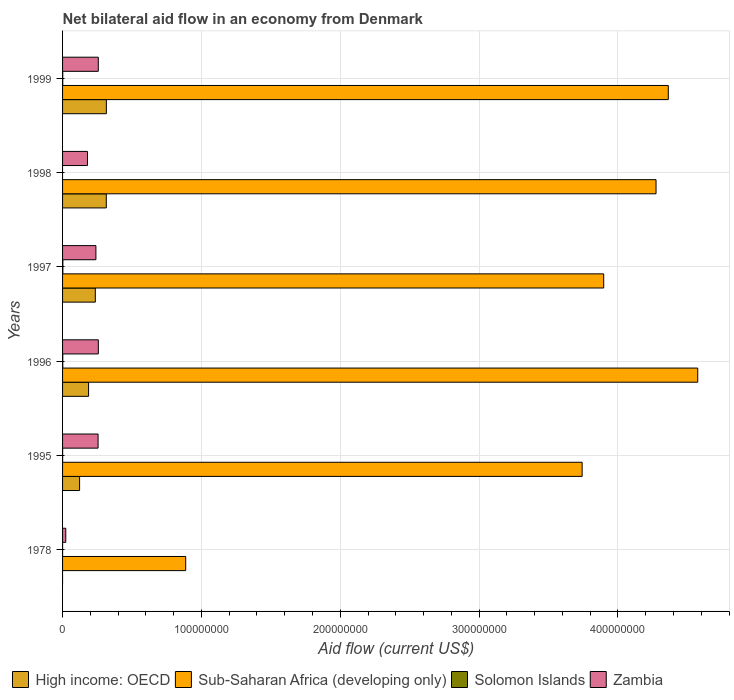Are the number of bars on each tick of the Y-axis equal?
Give a very brief answer. No. How many bars are there on the 4th tick from the top?
Ensure brevity in your answer.  4. How many bars are there on the 1st tick from the bottom?
Your response must be concise. 3. What is the label of the 1st group of bars from the top?
Your response must be concise. 1999. What is the net bilateral aid flow in High income: OECD in 1997?
Keep it short and to the point. 2.36e+07. Across all years, what is the maximum net bilateral aid flow in High income: OECD?
Your response must be concise. 3.15e+07. Across all years, what is the minimum net bilateral aid flow in Solomon Islands?
Provide a short and direct response. 0. In which year was the net bilateral aid flow in Zambia maximum?
Offer a very short reply. 1996. What is the total net bilateral aid flow in Sub-Saharan Africa (developing only) in the graph?
Make the answer very short. 2.17e+09. What is the difference between the net bilateral aid flow in High income: OECD in 1996 and that in 1997?
Provide a succinct answer. -4.87e+06. What is the difference between the net bilateral aid flow in Sub-Saharan Africa (developing only) in 1978 and the net bilateral aid flow in High income: OECD in 1999?
Your response must be concise. 5.71e+07. What is the average net bilateral aid flow in Zambia per year?
Provide a succinct answer. 2.02e+07. In the year 1997, what is the difference between the net bilateral aid flow in Zambia and net bilateral aid flow in Sub-Saharan Africa (developing only)?
Ensure brevity in your answer.  -3.66e+08. In how many years, is the net bilateral aid flow in Solomon Islands greater than 380000000 US$?
Your response must be concise. 0. What is the ratio of the net bilateral aid flow in High income: OECD in 1998 to that in 1999?
Provide a short and direct response. 1. Is the net bilateral aid flow in High income: OECD in 1996 less than that in 1999?
Offer a very short reply. Yes. Is the difference between the net bilateral aid flow in Zambia in 1995 and 1996 greater than the difference between the net bilateral aid flow in Sub-Saharan Africa (developing only) in 1995 and 1996?
Provide a succinct answer. Yes. Is it the case that in every year, the sum of the net bilateral aid flow in Zambia and net bilateral aid flow in Solomon Islands is greater than the net bilateral aid flow in Sub-Saharan Africa (developing only)?
Offer a terse response. No. Are all the bars in the graph horizontal?
Provide a succinct answer. Yes. Are the values on the major ticks of X-axis written in scientific E-notation?
Provide a succinct answer. No. Does the graph contain any zero values?
Your answer should be compact. Yes. Does the graph contain grids?
Provide a short and direct response. Yes. What is the title of the graph?
Your response must be concise. Net bilateral aid flow in an economy from Denmark. Does "Azerbaijan" appear as one of the legend labels in the graph?
Your answer should be very brief. No. What is the Aid flow (current US$) of Sub-Saharan Africa (developing only) in 1978?
Give a very brief answer. 8.87e+07. What is the Aid flow (current US$) of Zambia in 1978?
Your response must be concise. 2.31e+06. What is the Aid flow (current US$) of High income: OECD in 1995?
Offer a very short reply. 1.23e+07. What is the Aid flow (current US$) of Sub-Saharan Africa (developing only) in 1995?
Give a very brief answer. 3.74e+08. What is the Aid flow (current US$) of Solomon Islands in 1995?
Ensure brevity in your answer.  4.00e+04. What is the Aid flow (current US$) in Zambia in 1995?
Your answer should be compact. 2.56e+07. What is the Aid flow (current US$) of High income: OECD in 1996?
Offer a very short reply. 1.87e+07. What is the Aid flow (current US$) in Sub-Saharan Africa (developing only) in 1996?
Your answer should be compact. 4.57e+08. What is the Aid flow (current US$) of Solomon Islands in 1996?
Give a very brief answer. 1.50e+05. What is the Aid flow (current US$) in Zambia in 1996?
Make the answer very short. 2.58e+07. What is the Aid flow (current US$) in High income: OECD in 1997?
Your response must be concise. 2.36e+07. What is the Aid flow (current US$) in Sub-Saharan Africa (developing only) in 1997?
Your response must be concise. 3.90e+08. What is the Aid flow (current US$) in Zambia in 1997?
Make the answer very short. 2.40e+07. What is the Aid flow (current US$) in High income: OECD in 1998?
Provide a short and direct response. 3.15e+07. What is the Aid flow (current US$) of Sub-Saharan Africa (developing only) in 1998?
Keep it short and to the point. 4.27e+08. What is the Aid flow (current US$) of Zambia in 1998?
Offer a terse response. 1.79e+07. What is the Aid flow (current US$) of High income: OECD in 1999?
Offer a terse response. 3.15e+07. What is the Aid flow (current US$) of Sub-Saharan Africa (developing only) in 1999?
Provide a succinct answer. 4.36e+08. What is the Aid flow (current US$) in Zambia in 1999?
Offer a terse response. 2.57e+07. Across all years, what is the maximum Aid flow (current US$) of High income: OECD?
Your response must be concise. 3.15e+07. Across all years, what is the maximum Aid flow (current US$) of Sub-Saharan Africa (developing only)?
Offer a very short reply. 4.57e+08. Across all years, what is the maximum Aid flow (current US$) of Solomon Islands?
Give a very brief answer. 2.10e+05. Across all years, what is the maximum Aid flow (current US$) of Zambia?
Offer a very short reply. 2.58e+07. Across all years, what is the minimum Aid flow (current US$) of High income: OECD?
Your answer should be very brief. 0. Across all years, what is the minimum Aid flow (current US$) of Sub-Saharan Africa (developing only)?
Provide a succinct answer. 8.87e+07. Across all years, what is the minimum Aid flow (current US$) of Solomon Islands?
Your answer should be very brief. 0. Across all years, what is the minimum Aid flow (current US$) in Zambia?
Ensure brevity in your answer.  2.31e+06. What is the total Aid flow (current US$) in High income: OECD in the graph?
Your response must be concise. 1.18e+08. What is the total Aid flow (current US$) in Sub-Saharan Africa (developing only) in the graph?
Offer a terse response. 2.17e+09. What is the total Aid flow (current US$) of Solomon Islands in the graph?
Your response must be concise. 5.40e+05. What is the total Aid flow (current US$) in Zambia in the graph?
Provide a succinct answer. 1.21e+08. What is the difference between the Aid flow (current US$) of Sub-Saharan Africa (developing only) in 1978 and that in 1995?
Give a very brief answer. -2.86e+08. What is the difference between the Aid flow (current US$) of Solomon Islands in 1978 and that in 1995?
Provide a short and direct response. -3.00e+04. What is the difference between the Aid flow (current US$) in Zambia in 1978 and that in 1995?
Give a very brief answer. -2.33e+07. What is the difference between the Aid flow (current US$) in Sub-Saharan Africa (developing only) in 1978 and that in 1996?
Your response must be concise. -3.69e+08. What is the difference between the Aid flow (current US$) of Zambia in 1978 and that in 1996?
Keep it short and to the point. -2.34e+07. What is the difference between the Aid flow (current US$) in Sub-Saharan Africa (developing only) in 1978 and that in 1997?
Offer a very short reply. -3.01e+08. What is the difference between the Aid flow (current US$) in Zambia in 1978 and that in 1997?
Keep it short and to the point. -2.17e+07. What is the difference between the Aid flow (current US$) of Sub-Saharan Africa (developing only) in 1978 and that in 1998?
Ensure brevity in your answer.  -3.39e+08. What is the difference between the Aid flow (current US$) in Zambia in 1978 and that in 1998?
Keep it short and to the point. -1.56e+07. What is the difference between the Aid flow (current US$) in Sub-Saharan Africa (developing only) in 1978 and that in 1999?
Your answer should be very brief. -3.48e+08. What is the difference between the Aid flow (current US$) in Solomon Islands in 1978 and that in 1999?
Offer a terse response. -1.20e+05. What is the difference between the Aid flow (current US$) in Zambia in 1978 and that in 1999?
Give a very brief answer. -2.34e+07. What is the difference between the Aid flow (current US$) of High income: OECD in 1995 and that in 1996?
Your answer should be compact. -6.47e+06. What is the difference between the Aid flow (current US$) in Sub-Saharan Africa (developing only) in 1995 and that in 1996?
Make the answer very short. -8.32e+07. What is the difference between the Aid flow (current US$) of Solomon Islands in 1995 and that in 1996?
Make the answer very short. -1.10e+05. What is the difference between the Aid flow (current US$) in High income: OECD in 1995 and that in 1997?
Give a very brief answer. -1.13e+07. What is the difference between the Aid flow (current US$) of Sub-Saharan Africa (developing only) in 1995 and that in 1997?
Make the answer very short. -1.55e+07. What is the difference between the Aid flow (current US$) of Solomon Islands in 1995 and that in 1997?
Provide a succinct answer. -1.70e+05. What is the difference between the Aid flow (current US$) in Zambia in 1995 and that in 1997?
Provide a succinct answer. 1.57e+06. What is the difference between the Aid flow (current US$) in High income: OECD in 1995 and that in 1998?
Give a very brief answer. -1.92e+07. What is the difference between the Aid flow (current US$) of Sub-Saharan Africa (developing only) in 1995 and that in 1998?
Your answer should be very brief. -5.32e+07. What is the difference between the Aid flow (current US$) in Zambia in 1995 and that in 1998?
Offer a terse response. 7.64e+06. What is the difference between the Aid flow (current US$) of High income: OECD in 1995 and that in 1999?
Your answer should be compact. -1.93e+07. What is the difference between the Aid flow (current US$) in Sub-Saharan Africa (developing only) in 1995 and that in 1999?
Offer a terse response. -6.20e+07. What is the difference between the Aid flow (current US$) in High income: OECD in 1996 and that in 1997?
Offer a very short reply. -4.87e+06. What is the difference between the Aid flow (current US$) in Sub-Saharan Africa (developing only) in 1996 and that in 1997?
Give a very brief answer. 6.77e+07. What is the difference between the Aid flow (current US$) of Solomon Islands in 1996 and that in 1997?
Your answer should be very brief. -6.00e+04. What is the difference between the Aid flow (current US$) in Zambia in 1996 and that in 1997?
Provide a succinct answer. 1.74e+06. What is the difference between the Aid flow (current US$) of High income: OECD in 1996 and that in 1998?
Your answer should be compact. -1.28e+07. What is the difference between the Aid flow (current US$) in Sub-Saharan Africa (developing only) in 1996 and that in 1998?
Provide a short and direct response. 3.00e+07. What is the difference between the Aid flow (current US$) in Zambia in 1996 and that in 1998?
Your answer should be compact. 7.81e+06. What is the difference between the Aid flow (current US$) in High income: OECD in 1996 and that in 1999?
Give a very brief answer. -1.28e+07. What is the difference between the Aid flow (current US$) in Sub-Saharan Africa (developing only) in 1996 and that in 1999?
Keep it short and to the point. 2.12e+07. What is the difference between the Aid flow (current US$) in High income: OECD in 1997 and that in 1998?
Your answer should be compact. -7.90e+06. What is the difference between the Aid flow (current US$) of Sub-Saharan Africa (developing only) in 1997 and that in 1998?
Your answer should be very brief. -3.77e+07. What is the difference between the Aid flow (current US$) in Zambia in 1997 and that in 1998?
Your response must be concise. 6.07e+06. What is the difference between the Aid flow (current US$) of High income: OECD in 1997 and that in 1999?
Provide a short and direct response. -7.94e+06. What is the difference between the Aid flow (current US$) in Sub-Saharan Africa (developing only) in 1997 and that in 1999?
Your answer should be compact. -4.65e+07. What is the difference between the Aid flow (current US$) in Zambia in 1997 and that in 1999?
Offer a terse response. -1.72e+06. What is the difference between the Aid flow (current US$) in Sub-Saharan Africa (developing only) in 1998 and that in 1999?
Your answer should be very brief. -8.83e+06. What is the difference between the Aid flow (current US$) in Zambia in 1998 and that in 1999?
Provide a succinct answer. -7.79e+06. What is the difference between the Aid flow (current US$) in Sub-Saharan Africa (developing only) in 1978 and the Aid flow (current US$) in Solomon Islands in 1995?
Offer a very short reply. 8.86e+07. What is the difference between the Aid flow (current US$) in Sub-Saharan Africa (developing only) in 1978 and the Aid flow (current US$) in Zambia in 1995?
Your answer should be very brief. 6.31e+07. What is the difference between the Aid flow (current US$) in Solomon Islands in 1978 and the Aid flow (current US$) in Zambia in 1995?
Give a very brief answer. -2.56e+07. What is the difference between the Aid flow (current US$) in Sub-Saharan Africa (developing only) in 1978 and the Aid flow (current US$) in Solomon Islands in 1996?
Give a very brief answer. 8.85e+07. What is the difference between the Aid flow (current US$) of Sub-Saharan Africa (developing only) in 1978 and the Aid flow (current US$) of Zambia in 1996?
Offer a very short reply. 6.29e+07. What is the difference between the Aid flow (current US$) in Solomon Islands in 1978 and the Aid flow (current US$) in Zambia in 1996?
Keep it short and to the point. -2.57e+07. What is the difference between the Aid flow (current US$) in Sub-Saharan Africa (developing only) in 1978 and the Aid flow (current US$) in Solomon Islands in 1997?
Ensure brevity in your answer.  8.85e+07. What is the difference between the Aid flow (current US$) of Sub-Saharan Africa (developing only) in 1978 and the Aid flow (current US$) of Zambia in 1997?
Offer a terse response. 6.47e+07. What is the difference between the Aid flow (current US$) in Solomon Islands in 1978 and the Aid flow (current US$) in Zambia in 1997?
Make the answer very short. -2.40e+07. What is the difference between the Aid flow (current US$) of Sub-Saharan Africa (developing only) in 1978 and the Aid flow (current US$) of Zambia in 1998?
Offer a terse response. 7.07e+07. What is the difference between the Aid flow (current US$) of Solomon Islands in 1978 and the Aid flow (current US$) of Zambia in 1998?
Make the answer very short. -1.79e+07. What is the difference between the Aid flow (current US$) of Sub-Saharan Africa (developing only) in 1978 and the Aid flow (current US$) of Solomon Islands in 1999?
Provide a short and direct response. 8.86e+07. What is the difference between the Aid flow (current US$) of Sub-Saharan Africa (developing only) in 1978 and the Aid flow (current US$) of Zambia in 1999?
Make the answer very short. 6.30e+07. What is the difference between the Aid flow (current US$) in Solomon Islands in 1978 and the Aid flow (current US$) in Zambia in 1999?
Offer a terse response. -2.57e+07. What is the difference between the Aid flow (current US$) in High income: OECD in 1995 and the Aid flow (current US$) in Sub-Saharan Africa (developing only) in 1996?
Offer a terse response. -4.45e+08. What is the difference between the Aid flow (current US$) of High income: OECD in 1995 and the Aid flow (current US$) of Solomon Islands in 1996?
Ensure brevity in your answer.  1.21e+07. What is the difference between the Aid flow (current US$) of High income: OECD in 1995 and the Aid flow (current US$) of Zambia in 1996?
Make the answer very short. -1.35e+07. What is the difference between the Aid flow (current US$) in Sub-Saharan Africa (developing only) in 1995 and the Aid flow (current US$) in Solomon Islands in 1996?
Your answer should be compact. 3.74e+08. What is the difference between the Aid flow (current US$) of Sub-Saharan Africa (developing only) in 1995 and the Aid flow (current US$) of Zambia in 1996?
Your answer should be compact. 3.48e+08. What is the difference between the Aid flow (current US$) in Solomon Islands in 1995 and the Aid flow (current US$) in Zambia in 1996?
Your response must be concise. -2.57e+07. What is the difference between the Aid flow (current US$) in High income: OECD in 1995 and the Aid flow (current US$) in Sub-Saharan Africa (developing only) in 1997?
Ensure brevity in your answer.  -3.77e+08. What is the difference between the Aid flow (current US$) of High income: OECD in 1995 and the Aid flow (current US$) of Solomon Islands in 1997?
Keep it short and to the point. 1.20e+07. What is the difference between the Aid flow (current US$) of High income: OECD in 1995 and the Aid flow (current US$) of Zambia in 1997?
Your answer should be compact. -1.18e+07. What is the difference between the Aid flow (current US$) of Sub-Saharan Africa (developing only) in 1995 and the Aid flow (current US$) of Solomon Islands in 1997?
Your answer should be very brief. 3.74e+08. What is the difference between the Aid flow (current US$) in Sub-Saharan Africa (developing only) in 1995 and the Aid flow (current US$) in Zambia in 1997?
Your answer should be very brief. 3.50e+08. What is the difference between the Aid flow (current US$) in Solomon Islands in 1995 and the Aid flow (current US$) in Zambia in 1997?
Provide a succinct answer. -2.40e+07. What is the difference between the Aid flow (current US$) of High income: OECD in 1995 and the Aid flow (current US$) of Sub-Saharan Africa (developing only) in 1998?
Offer a very short reply. -4.15e+08. What is the difference between the Aid flow (current US$) of High income: OECD in 1995 and the Aid flow (current US$) of Zambia in 1998?
Offer a very short reply. -5.68e+06. What is the difference between the Aid flow (current US$) in Sub-Saharan Africa (developing only) in 1995 and the Aid flow (current US$) in Zambia in 1998?
Make the answer very short. 3.56e+08. What is the difference between the Aid flow (current US$) in Solomon Islands in 1995 and the Aid flow (current US$) in Zambia in 1998?
Give a very brief answer. -1.79e+07. What is the difference between the Aid flow (current US$) in High income: OECD in 1995 and the Aid flow (current US$) in Sub-Saharan Africa (developing only) in 1999?
Give a very brief answer. -4.24e+08. What is the difference between the Aid flow (current US$) of High income: OECD in 1995 and the Aid flow (current US$) of Solomon Islands in 1999?
Provide a succinct answer. 1.21e+07. What is the difference between the Aid flow (current US$) of High income: OECD in 1995 and the Aid flow (current US$) of Zambia in 1999?
Provide a short and direct response. -1.35e+07. What is the difference between the Aid flow (current US$) of Sub-Saharan Africa (developing only) in 1995 and the Aid flow (current US$) of Solomon Islands in 1999?
Provide a short and direct response. 3.74e+08. What is the difference between the Aid flow (current US$) in Sub-Saharan Africa (developing only) in 1995 and the Aid flow (current US$) in Zambia in 1999?
Offer a terse response. 3.48e+08. What is the difference between the Aid flow (current US$) in Solomon Islands in 1995 and the Aid flow (current US$) in Zambia in 1999?
Offer a terse response. -2.57e+07. What is the difference between the Aid flow (current US$) in High income: OECD in 1996 and the Aid flow (current US$) in Sub-Saharan Africa (developing only) in 1997?
Provide a short and direct response. -3.71e+08. What is the difference between the Aid flow (current US$) in High income: OECD in 1996 and the Aid flow (current US$) in Solomon Islands in 1997?
Offer a very short reply. 1.85e+07. What is the difference between the Aid flow (current US$) in High income: OECD in 1996 and the Aid flow (current US$) in Zambia in 1997?
Offer a very short reply. -5.28e+06. What is the difference between the Aid flow (current US$) of Sub-Saharan Africa (developing only) in 1996 and the Aid flow (current US$) of Solomon Islands in 1997?
Provide a succinct answer. 4.57e+08. What is the difference between the Aid flow (current US$) of Sub-Saharan Africa (developing only) in 1996 and the Aid flow (current US$) of Zambia in 1997?
Your response must be concise. 4.33e+08. What is the difference between the Aid flow (current US$) in Solomon Islands in 1996 and the Aid flow (current US$) in Zambia in 1997?
Offer a terse response. -2.39e+07. What is the difference between the Aid flow (current US$) of High income: OECD in 1996 and the Aid flow (current US$) of Sub-Saharan Africa (developing only) in 1998?
Give a very brief answer. -4.09e+08. What is the difference between the Aid flow (current US$) in High income: OECD in 1996 and the Aid flow (current US$) in Zambia in 1998?
Give a very brief answer. 7.90e+05. What is the difference between the Aid flow (current US$) in Sub-Saharan Africa (developing only) in 1996 and the Aid flow (current US$) in Zambia in 1998?
Your answer should be very brief. 4.40e+08. What is the difference between the Aid flow (current US$) of Solomon Islands in 1996 and the Aid flow (current US$) of Zambia in 1998?
Your answer should be very brief. -1.78e+07. What is the difference between the Aid flow (current US$) in High income: OECD in 1996 and the Aid flow (current US$) in Sub-Saharan Africa (developing only) in 1999?
Your response must be concise. -4.18e+08. What is the difference between the Aid flow (current US$) in High income: OECD in 1996 and the Aid flow (current US$) in Solomon Islands in 1999?
Give a very brief answer. 1.86e+07. What is the difference between the Aid flow (current US$) of High income: OECD in 1996 and the Aid flow (current US$) of Zambia in 1999?
Offer a terse response. -7.00e+06. What is the difference between the Aid flow (current US$) in Sub-Saharan Africa (developing only) in 1996 and the Aid flow (current US$) in Solomon Islands in 1999?
Ensure brevity in your answer.  4.57e+08. What is the difference between the Aid flow (current US$) in Sub-Saharan Africa (developing only) in 1996 and the Aid flow (current US$) in Zambia in 1999?
Keep it short and to the point. 4.32e+08. What is the difference between the Aid flow (current US$) in Solomon Islands in 1996 and the Aid flow (current US$) in Zambia in 1999?
Ensure brevity in your answer.  -2.56e+07. What is the difference between the Aid flow (current US$) in High income: OECD in 1997 and the Aid flow (current US$) in Sub-Saharan Africa (developing only) in 1998?
Provide a succinct answer. -4.04e+08. What is the difference between the Aid flow (current US$) in High income: OECD in 1997 and the Aid flow (current US$) in Zambia in 1998?
Provide a succinct answer. 5.66e+06. What is the difference between the Aid flow (current US$) of Sub-Saharan Africa (developing only) in 1997 and the Aid flow (current US$) of Zambia in 1998?
Keep it short and to the point. 3.72e+08. What is the difference between the Aid flow (current US$) in Solomon Islands in 1997 and the Aid flow (current US$) in Zambia in 1998?
Your answer should be compact. -1.77e+07. What is the difference between the Aid flow (current US$) of High income: OECD in 1997 and the Aid flow (current US$) of Sub-Saharan Africa (developing only) in 1999?
Ensure brevity in your answer.  -4.13e+08. What is the difference between the Aid flow (current US$) in High income: OECD in 1997 and the Aid flow (current US$) in Solomon Islands in 1999?
Ensure brevity in your answer.  2.35e+07. What is the difference between the Aid flow (current US$) of High income: OECD in 1997 and the Aid flow (current US$) of Zambia in 1999?
Your response must be concise. -2.13e+06. What is the difference between the Aid flow (current US$) in Sub-Saharan Africa (developing only) in 1997 and the Aid flow (current US$) in Solomon Islands in 1999?
Your response must be concise. 3.90e+08. What is the difference between the Aid flow (current US$) in Sub-Saharan Africa (developing only) in 1997 and the Aid flow (current US$) in Zambia in 1999?
Your answer should be compact. 3.64e+08. What is the difference between the Aid flow (current US$) of Solomon Islands in 1997 and the Aid flow (current US$) of Zambia in 1999?
Give a very brief answer. -2.55e+07. What is the difference between the Aid flow (current US$) in High income: OECD in 1998 and the Aid flow (current US$) in Sub-Saharan Africa (developing only) in 1999?
Your answer should be compact. -4.05e+08. What is the difference between the Aid flow (current US$) of High income: OECD in 1998 and the Aid flow (current US$) of Solomon Islands in 1999?
Keep it short and to the point. 3.14e+07. What is the difference between the Aid flow (current US$) in High income: OECD in 1998 and the Aid flow (current US$) in Zambia in 1999?
Provide a succinct answer. 5.77e+06. What is the difference between the Aid flow (current US$) of Sub-Saharan Africa (developing only) in 1998 and the Aid flow (current US$) of Solomon Islands in 1999?
Give a very brief answer. 4.27e+08. What is the difference between the Aid flow (current US$) of Sub-Saharan Africa (developing only) in 1998 and the Aid flow (current US$) of Zambia in 1999?
Give a very brief answer. 4.02e+08. What is the average Aid flow (current US$) in High income: OECD per year?
Your response must be concise. 1.96e+07. What is the average Aid flow (current US$) in Sub-Saharan Africa (developing only) per year?
Your answer should be very brief. 3.62e+08. What is the average Aid flow (current US$) of Solomon Islands per year?
Your answer should be compact. 9.00e+04. What is the average Aid flow (current US$) of Zambia per year?
Ensure brevity in your answer.  2.02e+07. In the year 1978, what is the difference between the Aid flow (current US$) of Sub-Saharan Africa (developing only) and Aid flow (current US$) of Solomon Islands?
Your response must be concise. 8.87e+07. In the year 1978, what is the difference between the Aid flow (current US$) in Sub-Saharan Africa (developing only) and Aid flow (current US$) in Zambia?
Make the answer very short. 8.64e+07. In the year 1978, what is the difference between the Aid flow (current US$) of Solomon Islands and Aid flow (current US$) of Zambia?
Make the answer very short. -2.30e+06. In the year 1995, what is the difference between the Aid flow (current US$) of High income: OECD and Aid flow (current US$) of Sub-Saharan Africa (developing only)?
Your answer should be very brief. -3.62e+08. In the year 1995, what is the difference between the Aid flow (current US$) in High income: OECD and Aid flow (current US$) in Solomon Islands?
Keep it short and to the point. 1.22e+07. In the year 1995, what is the difference between the Aid flow (current US$) of High income: OECD and Aid flow (current US$) of Zambia?
Provide a short and direct response. -1.33e+07. In the year 1995, what is the difference between the Aid flow (current US$) in Sub-Saharan Africa (developing only) and Aid flow (current US$) in Solomon Islands?
Make the answer very short. 3.74e+08. In the year 1995, what is the difference between the Aid flow (current US$) of Sub-Saharan Africa (developing only) and Aid flow (current US$) of Zambia?
Offer a very short reply. 3.49e+08. In the year 1995, what is the difference between the Aid flow (current US$) in Solomon Islands and Aid flow (current US$) in Zambia?
Your response must be concise. -2.55e+07. In the year 1996, what is the difference between the Aid flow (current US$) of High income: OECD and Aid flow (current US$) of Sub-Saharan Africa (developing only)?
Your response must be concise. -4.39e+08. In the year 1996, what is the difference between the Aid flow (current US$) of High income: OECD and Aid flow (current US$) of Solomon Islands?
Your answer should be compact. 1.86e+07. In the year 1996, what is the difference between the Aid flow (current US$) of High income: OECD and Aid flow (current US$) of Zambia?
Ensure brevity in your answer.  -7.02e+06. In the year 1996, what is the difference between the Aid flow (current US$) in Sub-Saharan Africa (developing only) and Aid flow (current US$) in Solomon Islands?
Provide a succinct answer. 4.57e+08. In the year 1996, what is the difference between the Aid flow (current US$) of Sub-Saharan Africa (developing only) and Aid flow (current US$) of Zambia?
Offer a terse response. 4.32e+08. In the year 1996, what is the difference between the Aid flow (current US$) of Solomon Islands and Aid flow (current US$) of Zambia?
Ensure brevity in your answer.  -2.56e+07. In the year 1997, what is the difference between the Aid flow (current US$) in High income: OECD and Aid flow (current US$) in Sub-Saharan Africa (developing only)?
Keep it short and to the point. -3.66e+08. In the year 1997, what is the difference between the Aid flow (current US$) in High income: OECD and Aid flow (current US$) in Solomon Islands?
Offer a terse response. 2.34e+07. In the year 1997, what is the difference between the Aid flow (current US$) of High income: OECD and Aid flow (current US$) of Zambia?
Your answer should be very brief. -4.10e+05. In the year 1997, what is the difference between the Aid flow (current US$) in Sub-Saharan Africa (developing only) and Aid flow (current US$) in Solomon Islands?
Your answer should be very brief. 3.90e+08. In the year 1997, what is the difference between the Aid flow (current US$) in Sub-Saharan Africa (developing only) and Aid flow (current US$) in Zambia?
Ensure brevity in your answer.  3.66e+08. In the year 1997, what is the difference between the Aid flow (current US$) of Solomon Islands and Aid flow (current US$) of Zambia?
Provide a short and direct response. -2.38e+07. In the year 1998, what is the difference between the Aid flow (current US$) of High income: OECD and Aid flow (current US$) of Sub-Saharan Africa (developing only)?
Offer a terse response. -3.96e+08. In the year 1998, what is the difference between the Aid flow (current US$) of High income: OECD and Aid flow (current US$) of Zambia?
Your answer should be very brief. 1.36e+07. In the year 1998, what is the difference between the Aid flow (current US$) of Sub-Saharan Africa (developing only) and Aid flow (current US$) of Zambia?
Offer a very short reply. 4.09e+08. In the year 1999, what is the difference between the Aid flow (current US$) in High income: OECD and Aid flow (current US$) in Sub-Saharan Africa (developing only)?
Provide a short and direct response. -4.05e+08. In the year 1999, what is the difference between the Aid flow (current US$) in High income: OECD and Aid flow (current US$) in Solomon Islands?
Give a very brief answer. 3.14e+07. In the year 1999, what is the difference between the Aid flow (current US$) in High income: OECD and Aid flow (current US$) in Zambia?
Keep it short and to the point. 5.81e+06. In the year 1999, what is the difference between the Aid flow (current US$) of Sub-Saharan Africa (developing only) and Aid flow (current US$) of Solomon Islands?
Make the answer very short. 4.36e+08. In the year 1999, what is the difference between the Aid flow (current US$) of Sub-Saharan Africa (developing only) and Aid flow (current US$) of Zambia?
Your response must be concise. 4.11e+08. In the year 1999, what is the difference between the Aid flow (current US$) of Solomon Islands and Aid flow (current US$) of Zambia?
Your answer should be compact. -2.56e+07. What is the ratio of the Aid flow (current US$) of Sub-Saharan Africa (developing only) in 1978 to that in 1995?
Give a very brief answer. 0.24. What is the ratio of the Aid flow (current US$) of Zambia in 1978 to that in 1995?
Your answer should be compact. 0.09. What is the ratio of the Aid flow (current US$) of Sub-Saharan Africa (developing only) in 1978 to that in 1996?
Provide a short and direct response. 0.19. What is the ratio of the Aid flow (current US$) in Solomon Islands in 1978 to that in 1996?
Provide a succinct answer. 0.07. What is the ratio of the Aid flow (current US$) in Zambia in 1978 to that in 1996?
Keep it short and to the point. 0.09. What is the ratio of the Aid flow (current US$) in Sub-Saharan Africa (developing only) in 1978 to that in 1997?
Provide a succinct answer. 0.23. What is the ratio of the Aid flow (current US$) of Solomon Islands in 1978 to that in 1997?
Keep it short and to the point. 0.05. What is the ratio of the Aid flow (current US$) of Zambia in 1978 to that in 1997?
Ensure brevity in your answer.  0.1. What is the ratio of the Aid flow (current US$) of Sub-Saharan Africa (developing only) in 1978 to that in 1998?
Offer a terse response. 0.21. What is the ratio of the Aid flow (current US$) in Zambia in 1978 to that in 1998?
Your answer should be compact. 0.13. What is the ratio of the Aid flow (current US$) in Sub-Saharan Africa (developing only) in 1978 to that in 1999?
Provide a short and direct response. 0.2. What is the ratio of the Aid flow (current US$) of Solomon Islands in 1978 to that in 1999?
Give a very brief answer. 0.08. What is the ratio of the Aid flow (current US$) in Zambia in 1978 to that in 1999?
Keep it short and to the point. 0.09. What is the ratio of the Aid flow (current US$) of High income: OECD in 1995 to that in 1996?
Keep it short and to the point. 0.65. What is the ratio of the Aid flow (current US$) of Sub-Saharan Africa (developing only) in 1995 to that in 1996?
Your response must be concise. 0.82. What is the ratio of the Aid flow (current US$) in Solomon Islands in 1995 to that in 1996?
Make the answer very short. 0.27. What is the ratio of the Aid flow (current US$) of Zambia in 1995 to that in 1996?
Provide a succinct answer. 0.99. What is the ratio of the Aid flow (current US$) in High income: OECD in 1995 to that in 1997?
Your answer should be very brief. 0.52. What is the ratio of the Aid flow (current US$) of Sub-Saharan Africa (developing only) in 1995 to that in 1997?
Your answer should be very brief. 0.96. What is the ratio of the Aid flow (current US$) in Solomon Islands in 1995 to that in 1997?
Your answer should be very brief. 0.19. What is the ratio of the Aid flow (current US$) in Zambia in 1995 to that in 1997?
Provide a succinct answer. 1.07. What is the ratio of the Aid flow (current US$) in High income: OECD in 1995 to that in 1998?
Your answer should be very brief. 0.39. What is the ratio of the Aid flow (current US$) of Sub-Saharan Africa (developing only) in 1995 to that in 1998?
Keep it short and to the point. 0.88. What is the ratio of the Aid flow (current US$) in Zambia in 1995 to that in 1998?
Your response must be concise. 1.43. What is the ratio of the Aid flow (current US$) of High income: OECD in 1995 to that in 1999?
Offer a very short reply. 0.39. What is the ratio of the Aid flow (current US$) of Sub-Saharan Africa (developing only) in 1995 to that in 1999?
Keep it short and to the point. 0.86. What is the ratio of the Aid flow (current US$) of Solomon Islands in 1995 to that in 1999?
Offer a terse response. 0.31. What is the ratio of the Aid flow (current US$) of High income: OECD in 1996 to that in 1997?
Make the answer very short. 0.79. What is the ratio of the Aid flow (current US$) in Sub-Saharan Africa (developing only) in 1996 to that in 1997?
Make the answer very short. 1.17. What is the ratio of the Aid flow (current US$) of Solomon Islands in 1996 to that in 1997?
Offer a terse response. 0.71. What is the ratio of the Aid flow (current US$) in Zambia in 1996 to that in 1997?
Provide a short and direct response. 1.07. What is the ratio of the Aid flow (current US$) of High income: OECD in 1996 to that in 1998?
Keep it short and to the point. 0.59. What is the ratio of the Aid flow (current US$) of Sub-Saharan Africa (developing only) in 1996 to that in 1998?
Your response must be concise. 1.07. What is the ratio of the Aid flow (current US$) in Zambia in 1996 to that in 1998?
Make the answer very short. 1.44. What is the ratio of the Aid flow (current US$) of High income: OECD in 1996 to that in 1999?
Your answer should be very brief. 0.59. What is the ratio of the Aid flow (current US$) of Sub-Saharan Africa (developing only) in 1996 to that in 1999?
Provide a succinct answer. 1.05. What is the ratio of the Aid flow (current US$) in Solomon Islands in 1996 to that in 1999?
Offer a terse response. 1.15. What is the ratio of the Aid flow (current US$) of Zambia in 1996 to that in 1999?
Ensure brevity in your answer.  1. What is the ratio of the Aid flow (current US$) in High income: OECD in 1997 to that in 1998?
Keep it short and to the point. 0.75. What is the ratio of the Aid flow (current US$) of Sub-Saharan Africa (developing only) in 1997 to that in 1998?
Offer a very short reply. 0.91. What is the ratio of the Aid flow (current US$) in Zambia in 1997 to that in 1998?
Make the answer very short. 1.34. What is the ratio of the Aid flow (current US$) of High income: OECD in 1997 to that in 1999?
Offer a terse response. 0.75. What is the ratio of the Aid flow (current US$) in Sub-Saharan Africa (developing only) in 1997 to that in 1999?
Provide a short and direct response. 0.89. What is the ratio of the Aid flow (current US$) of Solomon Islands in 1997 to that in 1999?
Your answer should be very brief. 1.62. What is the ratio of the Aid flow (current US$) in Zambia in 1997 to that in 1999?
Offer a terse response. 0.93. What is the ratio of the Aid flow (current US$) in High income: OECD in 1998 to that in 1999?
Your answer should be compact. 1. What is the ratio of the Aid flow (current US$) of Sub-Saharan Africa (developing only) in 1998 to that in 1999?
Make the answer very short. 0.98. What is the ratio of the Aid flow (current US$) in Zambia in 1998 to that in 1999?
Give a very brief answer. 0.7. What is the difference between the highest and the second highest Aid flow (current US$) of Sub-Saharan Africa (developing only)?
Offer a very short reply. 2.12e+07. What is the difference between the highest and the second highest Aid flow (current US$) in Solomon Islands?
Offer a very short reply. 6.00e+04. What is the difference between the highest and the second highest Aid flow (current US$) of Zambia?
Your answer should be very brief. 2.00e+04. What is the difference between the highest and the lowest Aid flow (current US$) in High income: OECD?
Give a very brief answer. 3.15e+07. What is the difference between the highest and the lowest Aid flow (current US$) in Sub-Saharan Africa (developing only)?
Provide a short and direct response. 3.69e+08. What is the difference between the highest and the lowest Aid flow (current US$) of Solomon Islands?
Your answer should be compact. 2.10e+05. What is the difference between the highest and the lowest Aid flow (current US$) of Zambia?
Your answer should be very brief. 2.34e+07. 